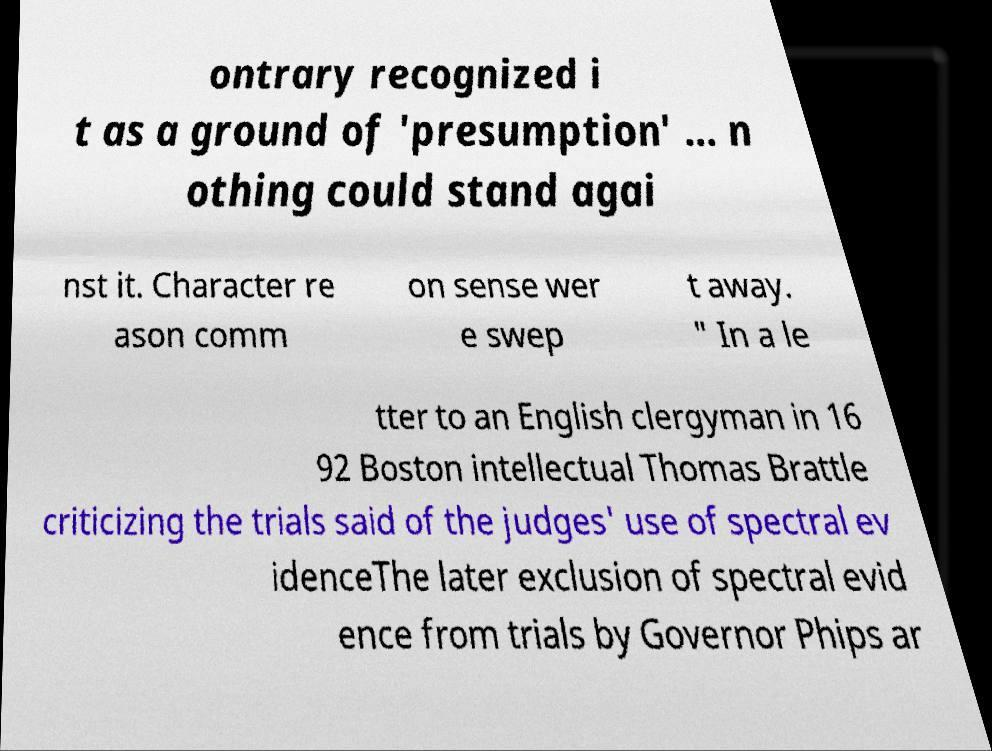I need the written content from this picture converted into text. Can you do that? ontrary recognized i t as a ground of 'presumption' … n othing could stand agai nst it. Character re ason comm on sense wer e swep t away. " In a le tter to an English clergyman in 16 92 Boston intellectual Thomas Brattle criticizing the trials said of the judges' use of spectral ev idenceThe later exclusion of spectral evid ence from trials by Governor Phips ar 